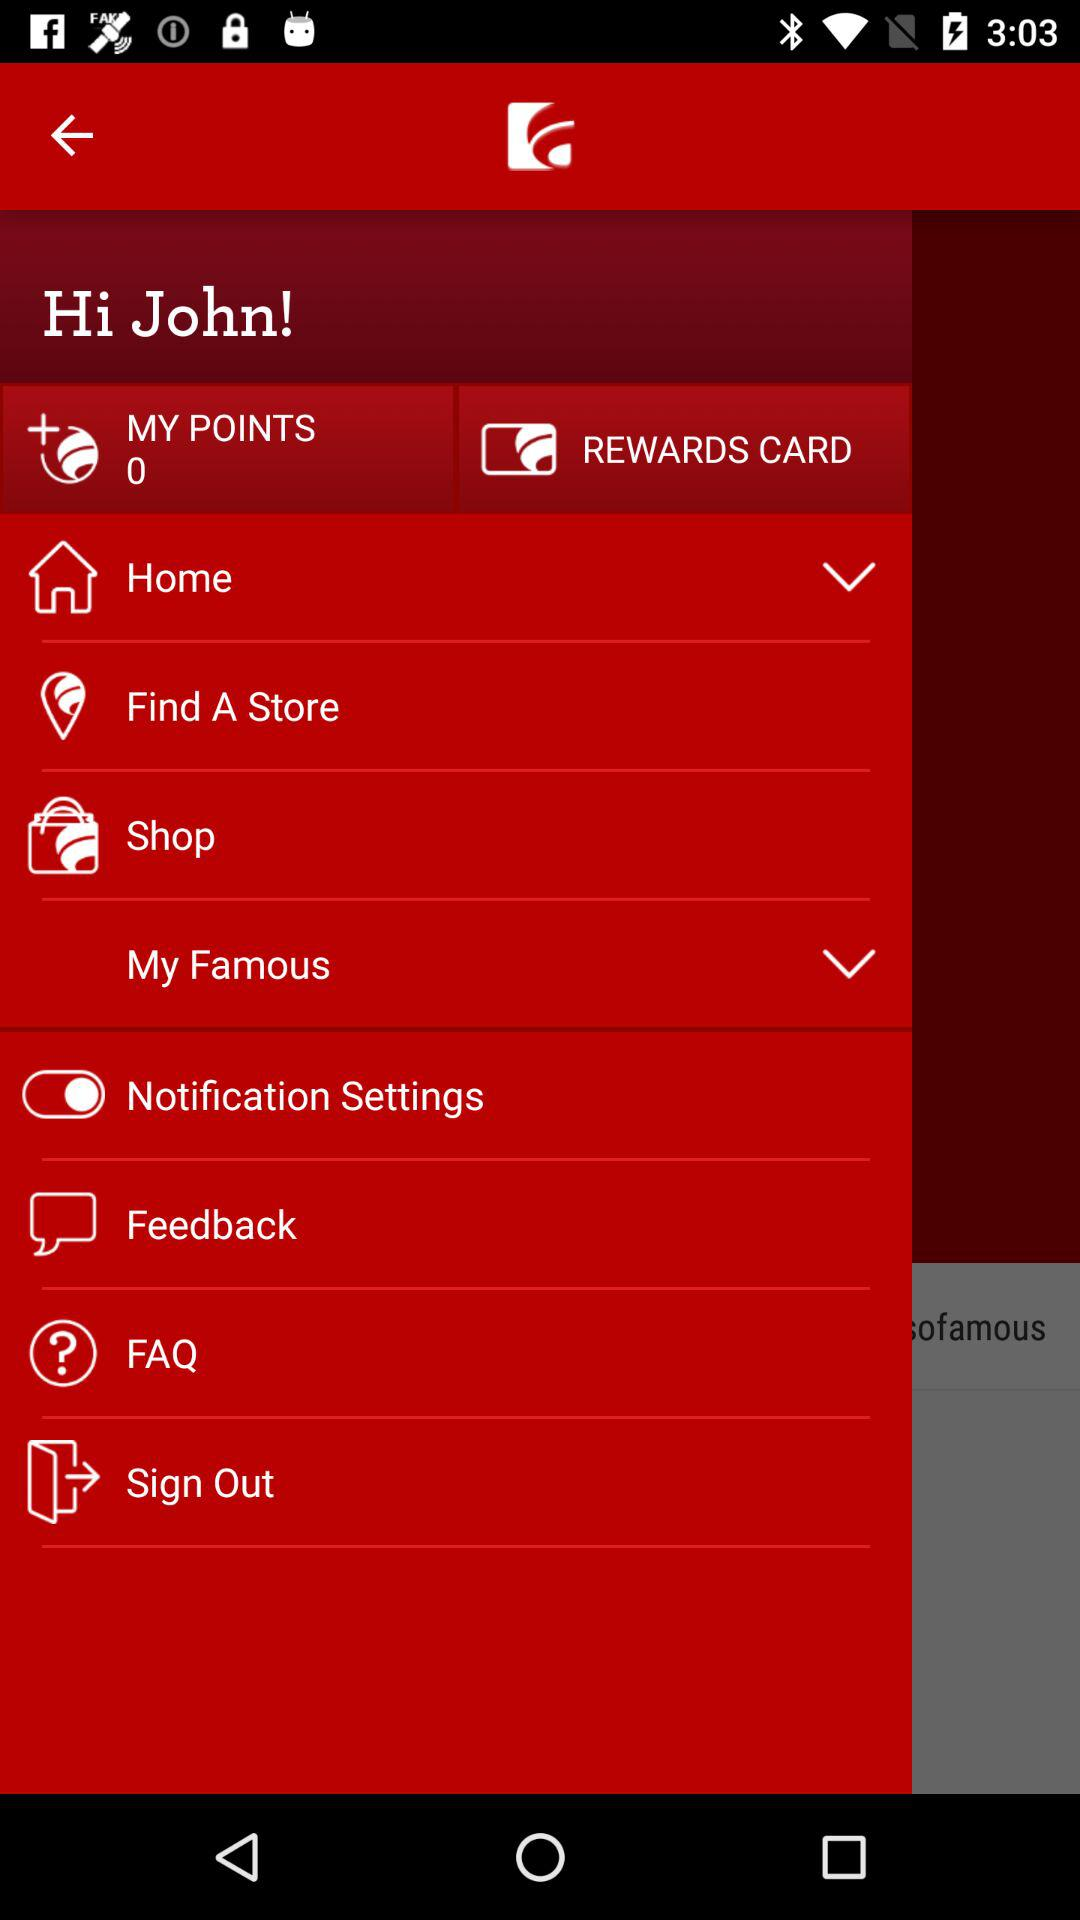What is the user name? The user name is John. 